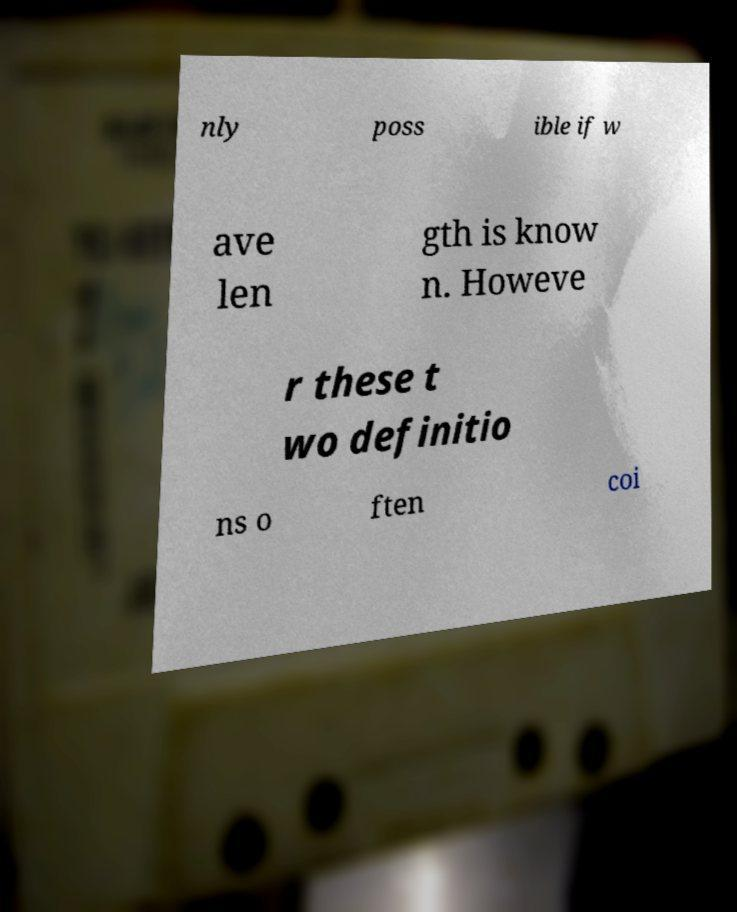There's text embedded in this image that I need extracted. Can you transcribe it verbatim? nly poss ible if w ave len gth is know n. Howeve r these t wo definitio ns o ften coi 